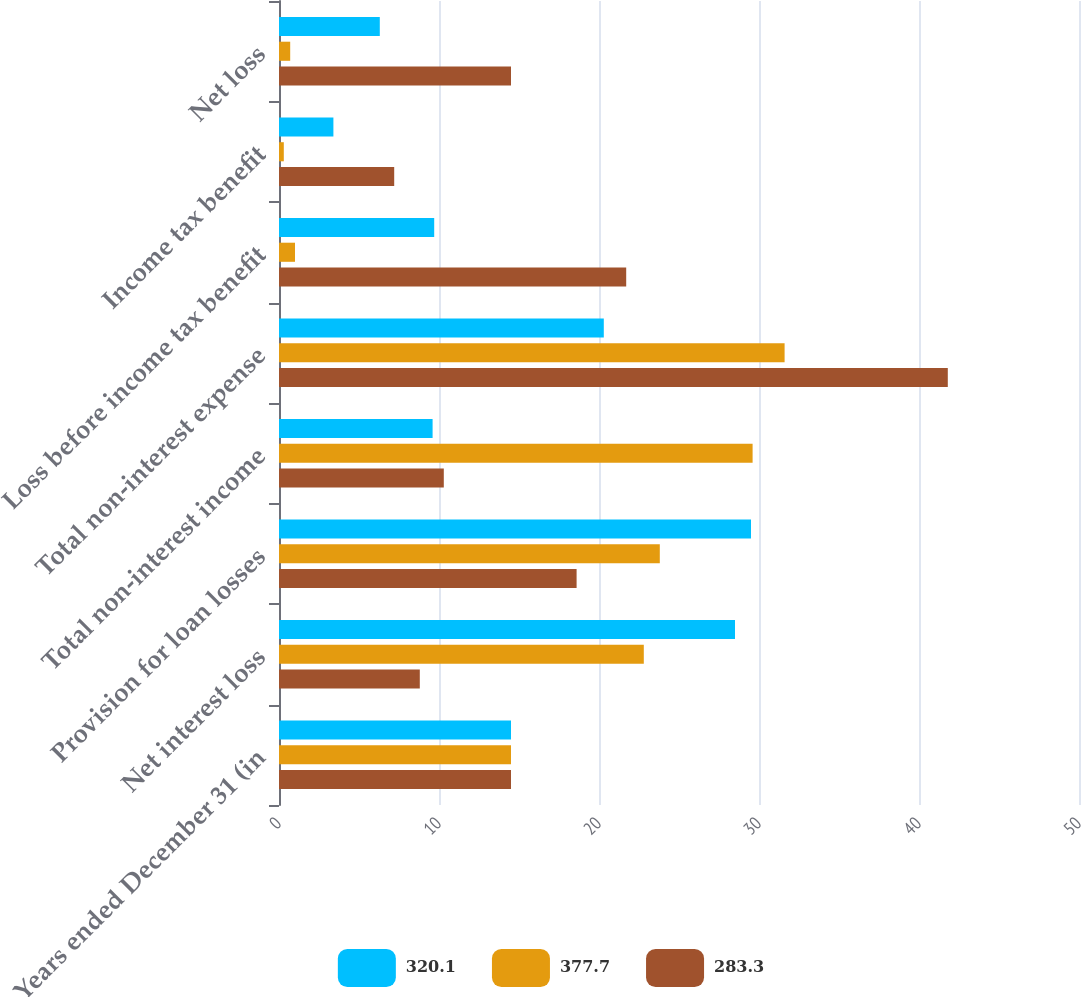Convert chart. <chart><loc_0><loc_0><loc_500><loc_500><stacked_bar_chart><ecel><fcel>Years ended December 31 (in<fcel>Net interest loss<fcel>Provision for loan losses<fcel>Total non-interest income<fcel>Total non-interest expense<fcel>Loss before income tax benefit<fcel>Income tax benefit<fcel>Net loss<nl><fcel>320.1<fcel>14.5<fcel>28.5<fcel>29.5<fcel>9.6<fcel>20.3<fcel>9.7<fcel>3.4<fcel>6.3<nl><fcel>377.7<fcel>14.5<fcel>22.8<fcel>23.8<fcel>29.6<fcel>31.6<fcel>1<fcel>0.3<fcel>0.7<nl><fcel>283.3<fcel>14.5<fcel>8.8<fcel>18.6<fcel>10.3<fcel>41.8<fcel>21.7<fcel>7.2<fcel>14.5<nl></chart> 